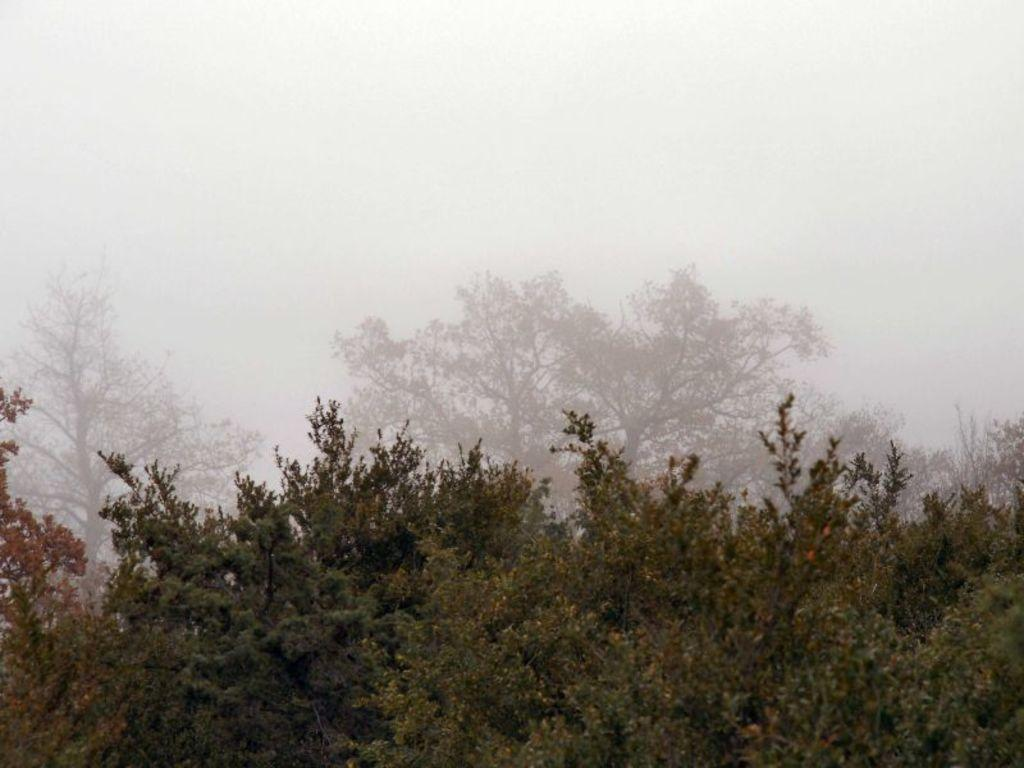What type of vegetation is present in the image? There are trees with green leaves in the image. What is the condition of the leaves on the trees? The leaves are on the ground. What can be seen in the background of the image? There is smoke and clouds in the sky in the background of the image. What is your sister doing in the image? There is no reference to a sister in the image, so it is not possible to answer that question. 